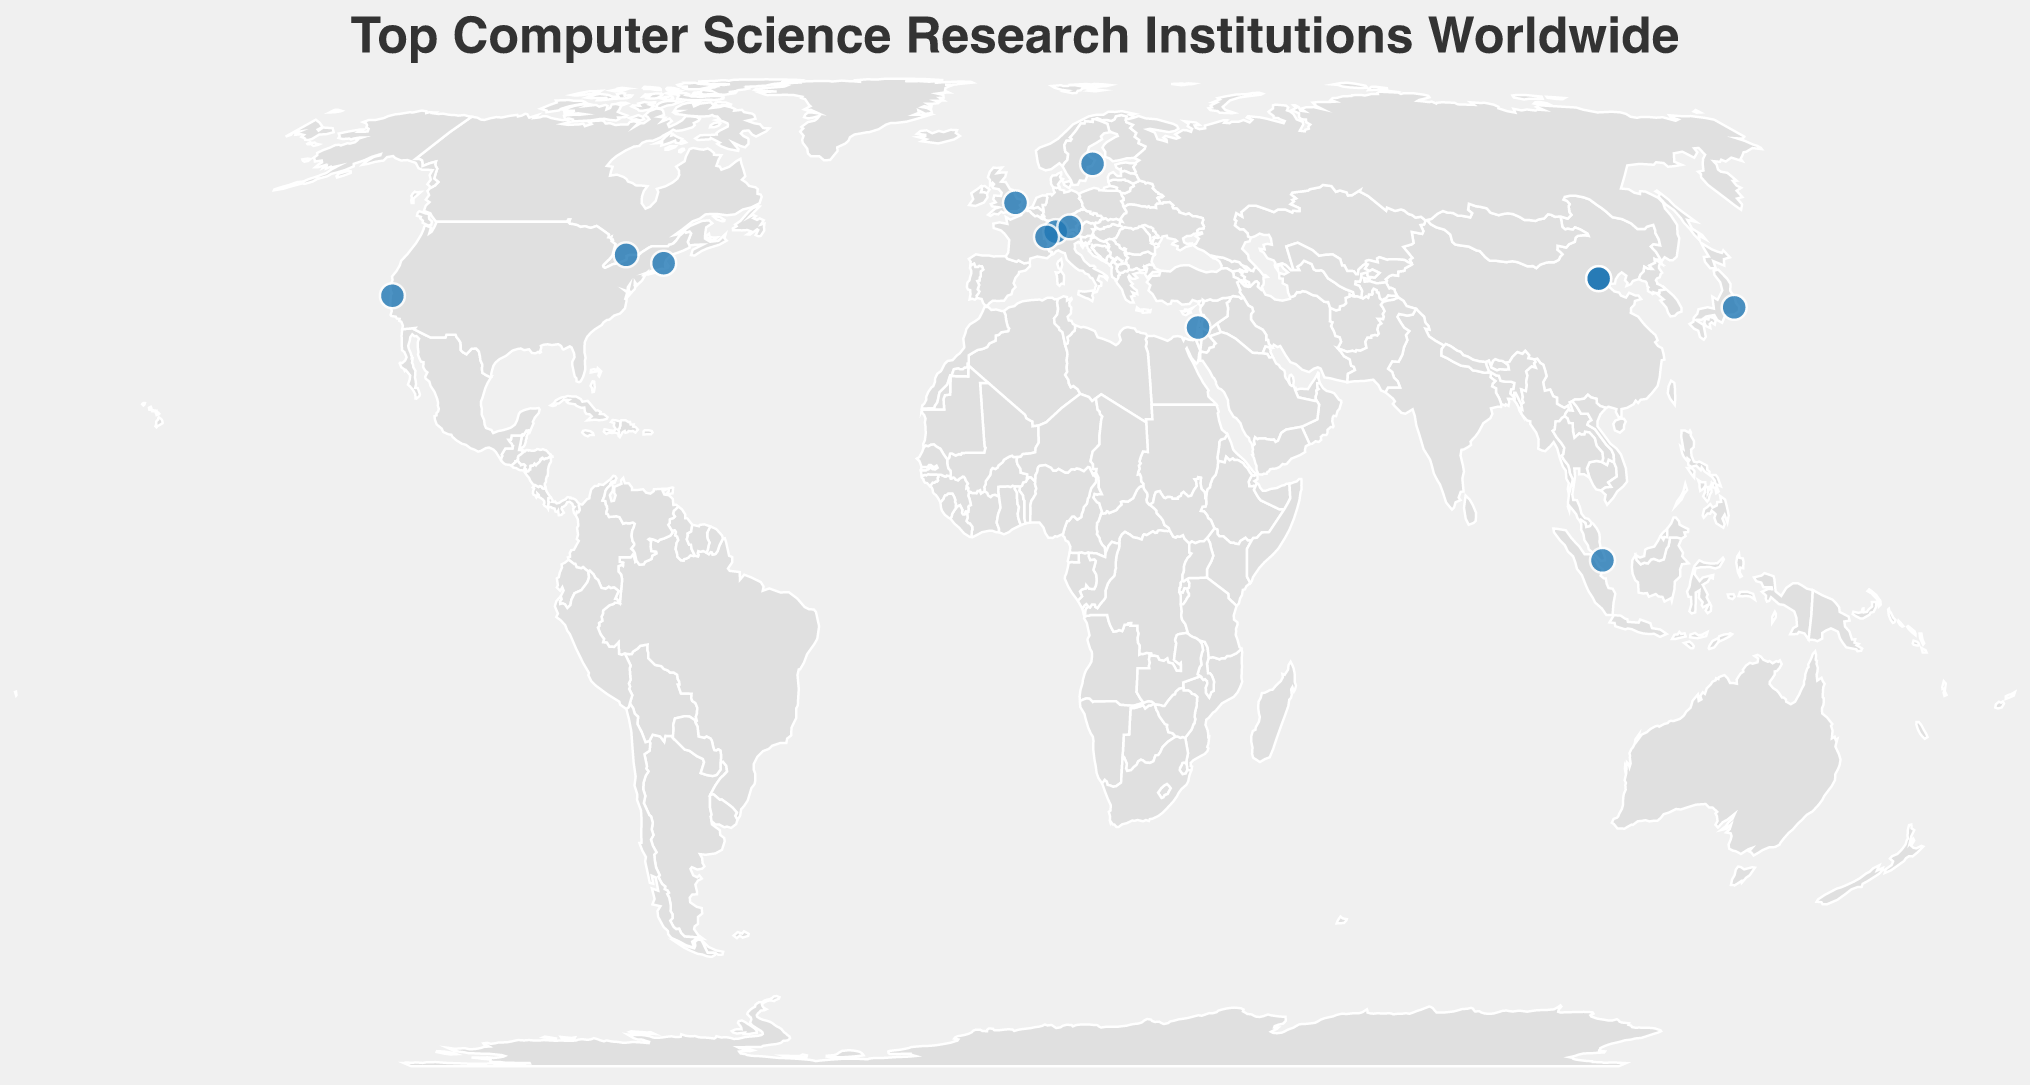Which institution is located in Germany? By looking at the plotted points and referring to the tooltip information, we can see that Technical University of Munich is located in Germany.
Answer: Technical University of Munich Which institutions are represented with both a primary language and English? We need to identify all points where the tooltip indicates both a primary language and English. These institutions are ETH Zurich (German/English), Tsinghua University (Chinese/English), Technical University of Munich (German/English), University of Tokyo (Japanese/English), École Polytechnique Fédérale de Lausanne (French/English), Peking University (Chinese/English), and Technion - Israel Institute of Technology (Hebrew/English).
Answer: ETH Zurich, Tsinghua University, Technical University of Munich, University of Tokyo, École Polytechnique Fédérale de Lausanne, Peking University, Technion - Israel Institute of Technology How many institutions are located in Asia? We need to count the number of points plotted on the Asian continent. The institutions in Asia are Tsinghua University (China), National University of Singapore (Singapore), University of Tokyo (Japan), Peking University (China), and Technion - Israel Institute of Technology (Israel). Thus, there are 5 institutions in Asia.
Answer: 5 Which institution is found furthest north? By looking at the latitude values in the tooltip, we can identify the highest latitude. KTH Royal Institute of Technology in Sweden is at latitude 59.3498, making it the northernmost institution.
Answer: KTH Royal Institute of Technology How many institutions primarily use English in their instruction? We need to analyze the tooltip data to count institutions where the primary or one of the languages of instruction is English. The institutions are Massachusetts Institute of Technology, Stanford University, ETH Zurich, University of Cambridge, Tsinghua University, National University of Singapore, Technical University of Munich, University of Tokyo, École Polytechnique Fédérale de Lausanne, University of Toronto, Technion - Israel Institute of Technology, Peking University, and KTH Royal Institute of Technology. This totals 13 institutions.
Answer: 13 